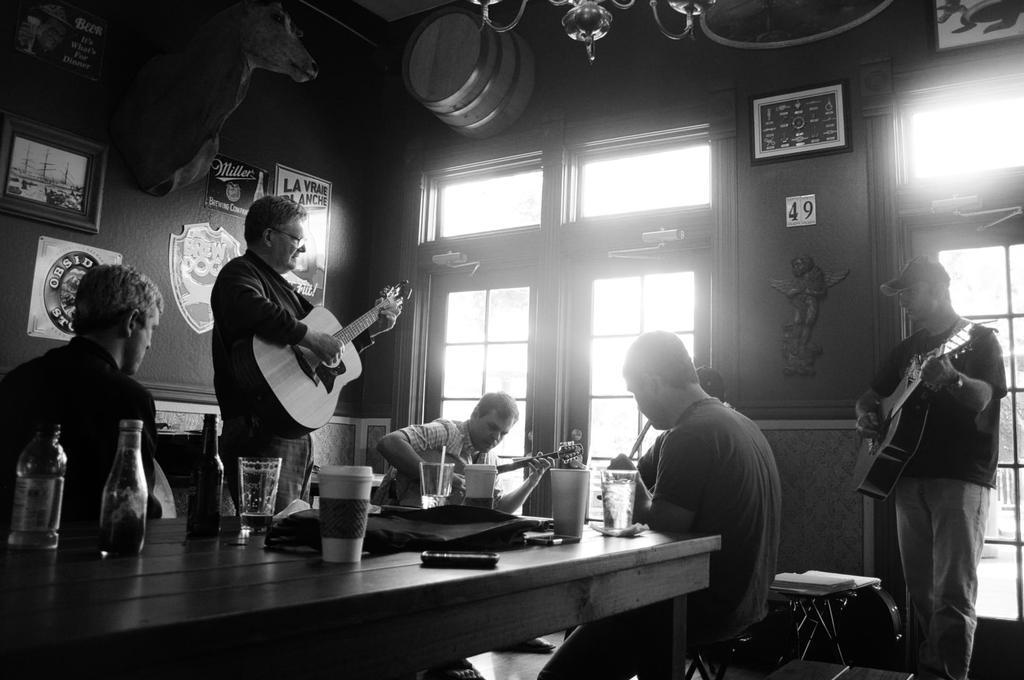Can you describe this image briefly? On the right there is a man he wear trouser and cap. he is playing guitar. In the middle there is a table on that table there is a glass,cup ,bottle ,mobile and some other items. On the left there is a man he is playing guitar. In the background there is window ,glass,poster,wall and photo frame. 